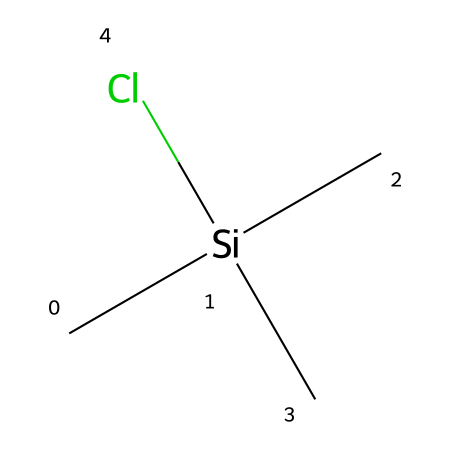What is the name of this chemical? The SMILES representation shows a silicon atom bonded to three methyl groups (C) and one chlorine atom (Cl). The standard naming convention for a compound with this structure is trimethylsilyl chloride.
Answer: trimethylsilyl chloride How many carbon atoms are present in this compound? The chemical structure has three methyl groups, each containing one carbon atom. Therefore, there are three carbon atoms total in the compound.
Answer: three What type of chemical bond exists between silicon and chlorine? In the given compound, the silicon (Si) atom is bonded to a chlorine (Cl) atom through a single covalent bond, which is typical for organosilicon compounds with halogen substituents.
Answer: covalent What is the hybridization of the silicon atom in this molecule? The silicon atom in trimethylsilyl chloride is bonded to three carbon atoms and one chlorine atom, resulting in a tetrahedral geometry. The hybridization of silicon in this configuration is sp3.
Answer: sp3 How many total bonds are present in the molecule? The compound has three C-Si bonds (from the three methyl groups) and one Si-Cl bond, resulting in a total of four bonds.
Answer: four What functional group is represented in this chemical? The presence of a chlorine atom directly bonded to the silicon atom indicates that this compound belongs to the functional group of organosilicon halides.
Answer: organosilicon halide Which feature of this compound contributes to its utility in aviation-grade adhesives? The presence of the trimethylsilyl group enhances the chemical's reactivity and compatibility with various substrates, which is beneficial for adhesion applications.
Answer: trimethylsilyl group 